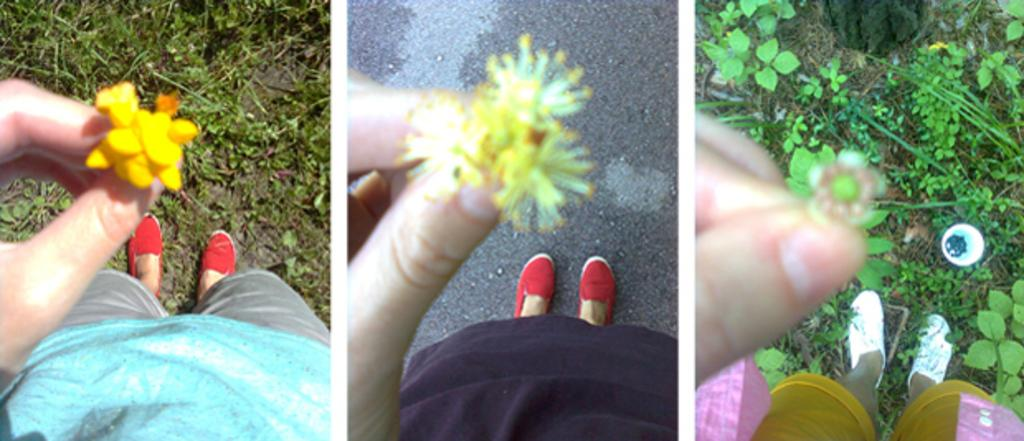Who is the main subject in the image? There is a lady in the image. Where is the lady located in the image? The lady is at the bottom side of the image. What is the lady holding in her hand? The lady is holding a flower in her hand. What can be inferred about the setting of the image? The image appears to be set in a college. What songs are being sung by the lady in the image? There is no indication in the image that the lady is singing any songs, so it cannot be determined from the picture. 